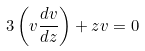Convert formula to latex. <formula><loc_0><loc_0><loc_500><loc_500>3 \left ( v \frac { d v } { d z } \right ) + z v = 0</formula> 